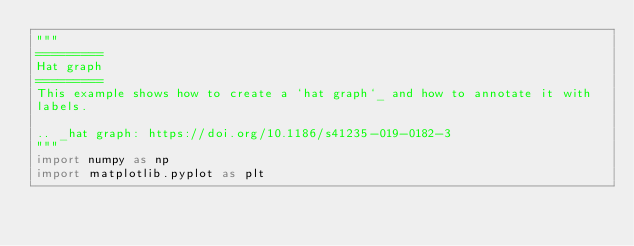Convert code to text. <code><loc_0><loc_0><loc_500><loc_500><_Python_>"""
=========
Hat graph
=========
This example shows how to create a `hat graph`_ and how to annotate it with
labels.

.. _hat graph: https://doi.org/10.1186/s41235-019-0182-3
"""
import numpy as np
import matplotlib.pyplot as plt

</code> 